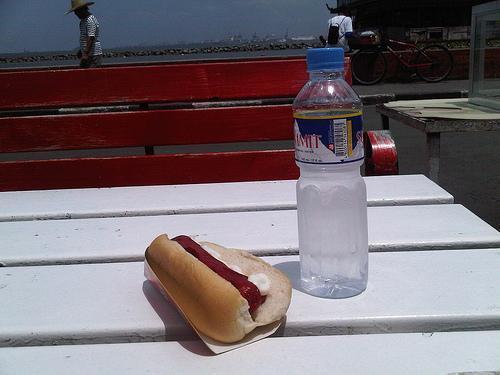How many hot dogs are there?
Give a very brief answer. 1. How many people are shown?
Give a very brief answer. 2. How many bikes are shown?
Give a very brief answer. 1. How many water in the table?
Give a very brief answer. 1. How many water bottles are pictured?
Give a very brief answer. 1. 